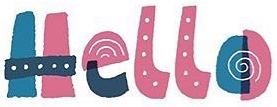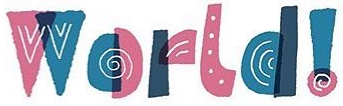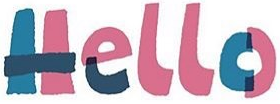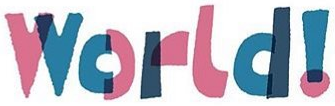What text appears in these images from left to right, separated by a semicolon? Hello; World!; Hello; World! 